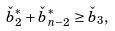Convert formula to latex. <formula><loc_0><loc_0><loc_500><loc_500>\check { b } ^ { * } _ { 2 } + \check { b } ^ { * } _ { n - 2 } \geq \check { b } _ { 3 } ,</formula> 